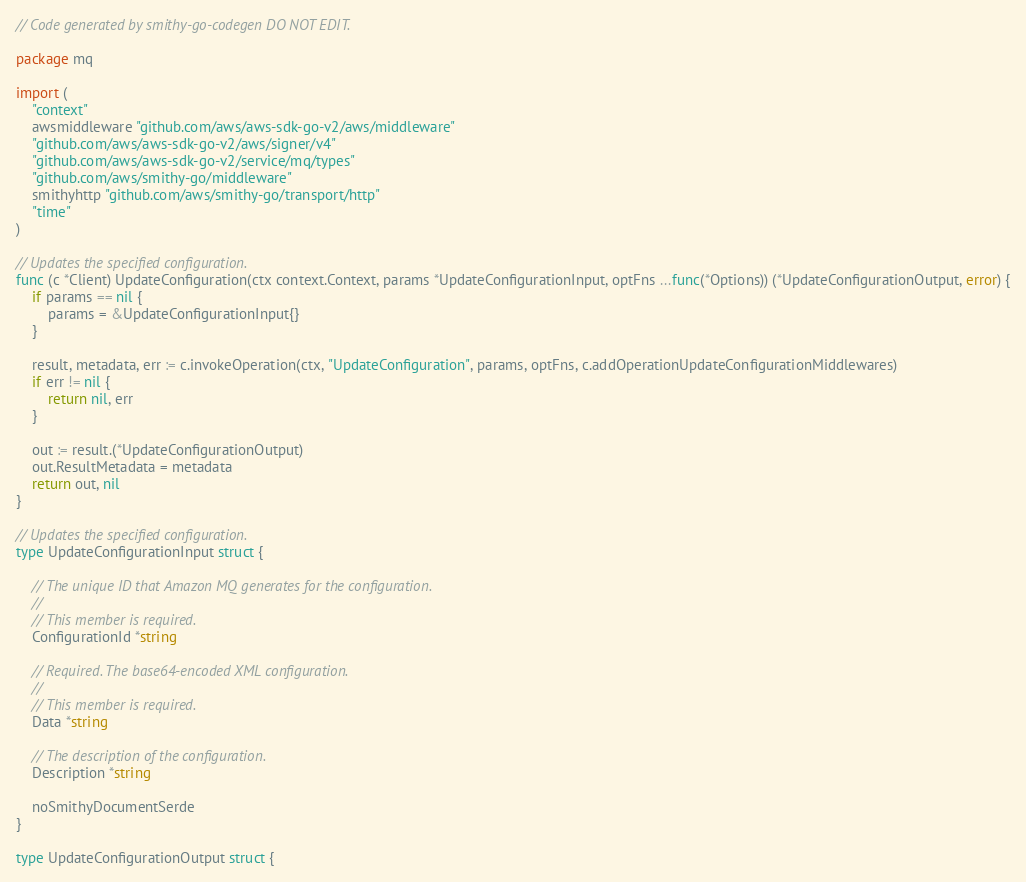<code> <loc_0><loc_0><loc_500><loc_500><_Go_>// Code generated by smithy-go-codegen DO NOT EDIT.

package mq

import (
	"context"
	awsmiddleware "github.com/aws/aws-sdk-go-v2/aws/middleware"
	"github.com/aws/aws-sdk-go-v2/aws/signer/v4"
	"github.com/aws/aws-sdk-go-v2/service/mq/types"
	"github.com/aws/smithy-go/middleware"
	smithyhttp "github.com/aws/smithy-go/transport/http"
	"time"
)

// Updates the specified configuration.
func (c *Client) UpdateConfiguration(ctx context.Context, params *UpdateConfigurationInput, optFns ...func(*Options)) (*UpdateConfigurationOutput, error) {
	if params == nil {
		params = &UpdateConfigurationInput{}
	}

	result, metadata, err := c.invokeOperation(ctx, "UpdateConfiguration", params, optFns, c.addOperationUpdateConfigurationMiddlewares)
	if err != nil {
		return nil, err
	}

	out := result.(*UpdateConfigurationOutput)
	out.ResultMetadata = metadata
	return out, nil
}

// Updates the specified configuration.
type UpdateConfigurationInput struct {

	// The unique ID that Amazon MQ generates for the configuration.
	//
	// This member is required.
	ConfigurationId *string

	// Required. The base64-encoded XML configuration.
	//
	// This member is required.
	Data *string

	// The description of the configuration.
	Description *string

	noSmithyDocumentSerde
}

type UpdateConfigurationOutput struct {
</code> 